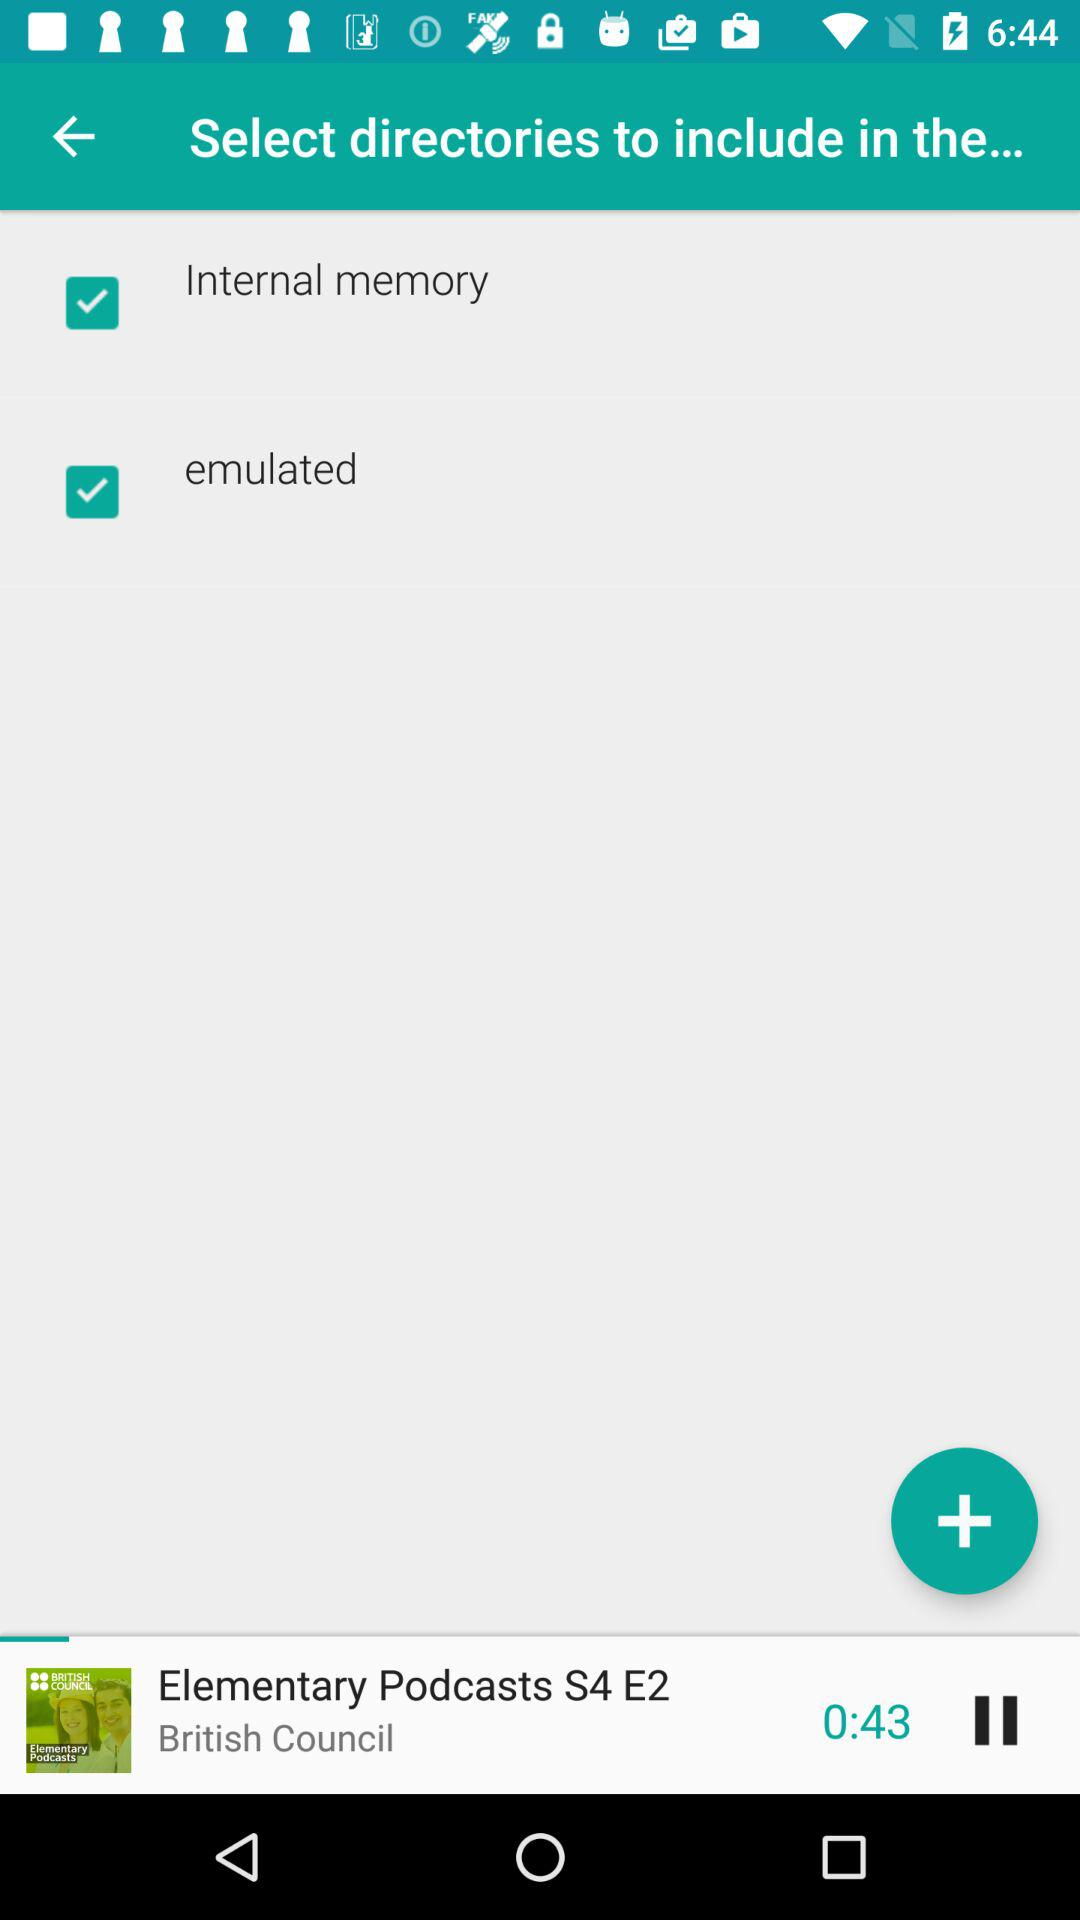What is the current status of "emulated"? The current status of "emulated" is "on". 